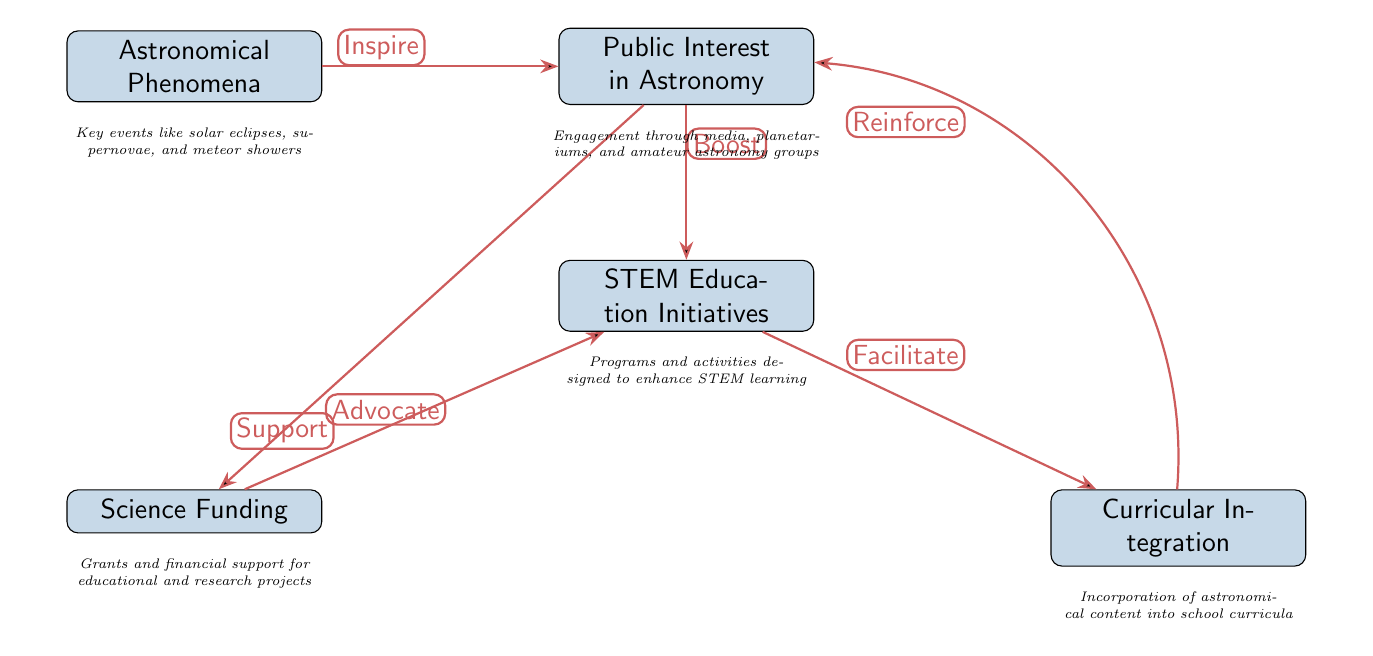What are the five main nodes in the diagram? The diagram features five main nodes: "Astronomical Phenomena," "Public Interest in Astronomy," "STEM Education Initiatives," "Science Funding," and "Curricular Integration."
Answer: Five What label is associated with the edge from "Interest" to "STEM"? The edge from "Interest" to "STEM" is labeled "Boost," indicating a positive correlation between public interest in astronomy and STEM education initiatives.
Answer: Boost How many edges are present in the diagram? There are six edges connecting the nodes, showing the relationships and influences between them.
Answer: Six What action does "Science Funding" take towards "STEM Education Initiatives"? "Science Funding" is indicated to "Support" STEM Education Initiatives, which shows that financial backing plays a role in promoting STEM education.
Answer: Support Which node reinforces the connection back to "Public Interest in Astronomy"? "Curricular Integration" reinforces the connection back to "Public Interest in Astronomy," suggesting that integrating astronomy into curricula strengthens public engagement.
Answer: Curricular Integration How does "Astronomical Phenomena" influence "Public Interest in Astronomy"? "Astronomical Phenomena" inspires "Public Interest in Astronomy," meaning that events like eclipses and meteor showers stimulate public curiosity and excitement.
Answer: Inspire Which two nodes are connected by the edge labeled "Facilitate"? The edge labeled "Facilitate" connects "STEM Education Initiatives" and "Curricular Integration," indicating that initiatives in STEM help integrate astronomical content into education.
Answer: STEM Education Initiatives and Curricular Integration What is the role of "Interest" in relation to "Science Funding"? "Interest" advocates for "Science Funding," showing that increased public interest drives efforts to secure funding for scientific and educational projects.
Answer: Advocate How does "STEM Education Initiatives" affect "Curricular Integration"? "STEM Education Initiatives" facilitate "Curricular Integration," indicating that programs designed to enhance STEM education help embed astronomy in school curricula.
Answer: Facilitate 